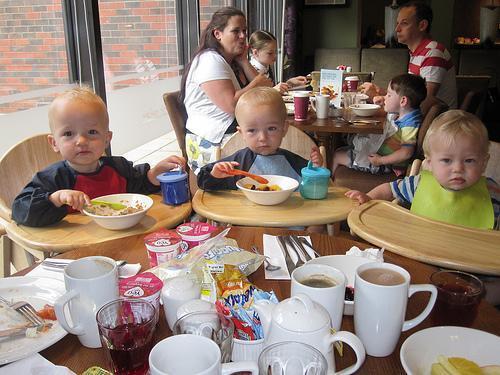How many babies are seen?
Give a very brief answer. 3. 